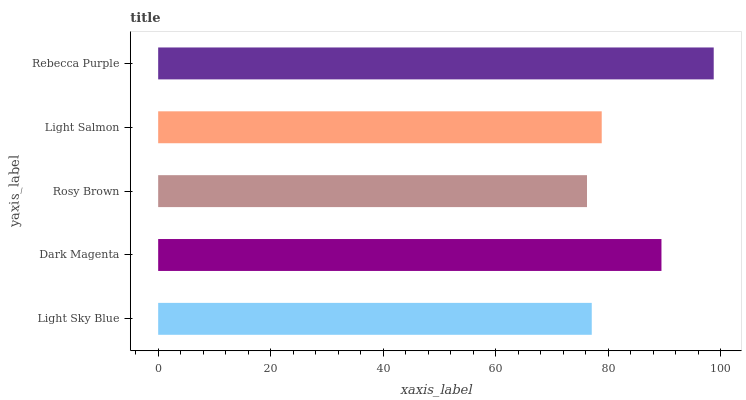Is Rosy Brown the minimum?
Answer yes or no. Yes. Is Rebecca Purple the maximum?
Answer yes or no. Yes. Is Dark Magenta the minimum?
Answer yes or no. No. Is Dark Magenta the maximum?
Answer yes or no. No. Is Dark Magenta greater than Light Sky Blue?
Answer yes or no. Yes. Is Light Sky Blue less than Dark Magenta?
Answer yes or no. Yes. Is Light Sky Blue greater than Dark Magenta?
Answer yes or no. No. Is Dark Magenta less than Light Sky Blue?
Answer yes or no. No. Is Light Salmon the high median?
Answer yes or no. Yes. Is Light Salmon the low median?
Answer yes or no. Yes. Is Rebecca Purple the high median?
Answer yes or no. No. Is Rosy Brown the low median?
Answer yes or no. No. 